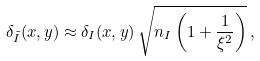Convert formula to latex. <formula><loc_0><loc_0><loc_500><loc_500>\delta _ { \tilde { I } } ( x , y ) \approx \delta _ { I } ( x , y ) \, \sqrt { n _ { I } \left ( 1 + \frac { 1 } { \xi ^ { 2 } } \right ) } \, ,</formula> 